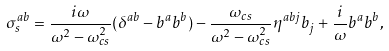<formula> <loc_0><loc_0><loc_500><loc_500>\sigma _ { s } ^ { a b } = \frac { i \omega } { \omega ^ { 2 } - \omega _ { c s } ^ { 2 } } ( \delta ^ { a b } - b ^ { a } b ^ { b } ) - \frac { \omega _ { c s } } { \omega ^ { 2 } - \omega _ { c s } ^ { 2 } } \eta ^ { a b j } b _ { j } + \frac { i } { \omega } b ^ { a } b ^ { b } ,</formula> 